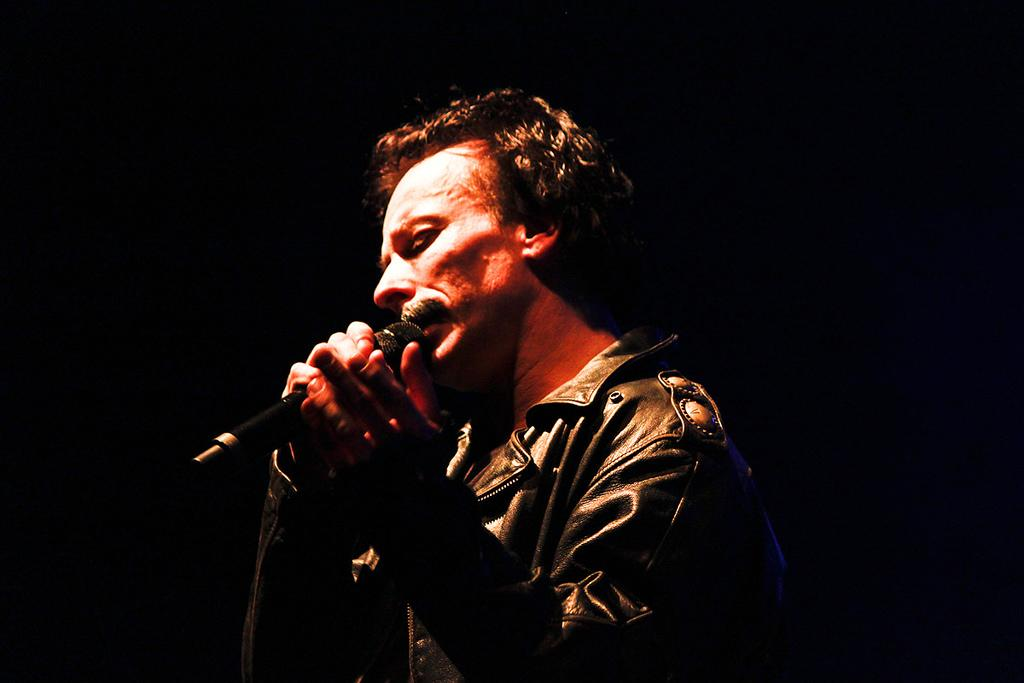What is the main subject of the image? There is a person in the image. What is the person wearing? The person is wearing a jacket. What is the person holding in the image? The person is holding a mic. What type of force can be seen affecting the leather in the image? There is no leather present in the image, and therefore no force can be seen affecting it. 